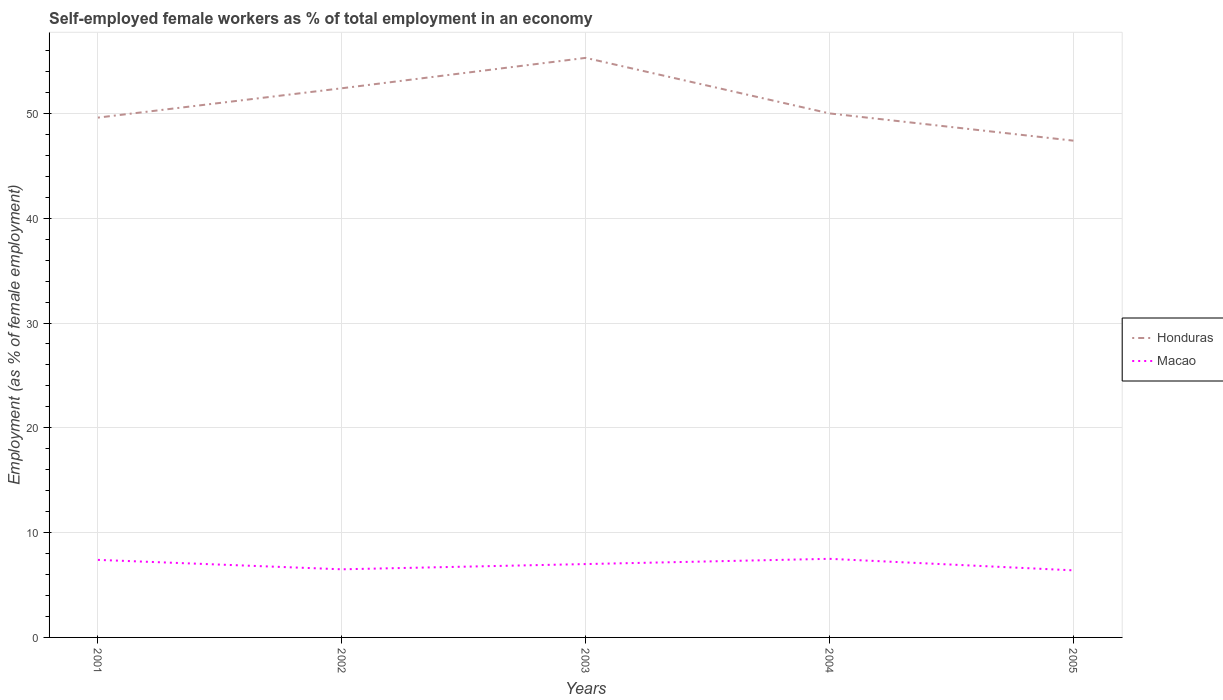How many different coloured lines are there?
Make the answer very short. 2. Does the line corresponding to Honduras intersect with the line corresponding to Macao?
Your answer should be compact. No. Is the number of lines equal to the number of legend labels?
Provide a succinct answer. Yes. Across all years, what is the maximum percentage of self-employed female workers in Honduras?
Your answer should be very brief. 47.4. What is the difference between the highest and the second highest percentage of self-employed female workers in Honduras?
Make the answer very short. 7.9. Is the percentage of self-employed female workers in Macao strictly greater than the percentage of self-employed female workers in Honduras over the years?
Keep it short and to the point. Yes. How many years are there in the graph?
Offer a terse response. 5. How are the legend labels stacked?
Offer a very short reply. Vertical. What is the title of the graph?
Make the answer very short. Self-employed female workers as % of total employment in an economy. Does "Guatemala" appear as one of the legend labels in the graph?
Make the answer very short. No. What is the label or title of the X-axis?
Ensure brevity in your answer.  Years. What is the label or title of the Y-axis?
Your answer should be very brief. Employment (as % of female employment). What is the Employment (as % of female employment) in Honduras in 2001?
Offer a very short reply. 49.6. What is the Employment (as % of female employment) in Macao in 2001?
Keep it short and to the point. 7.4. What is the Employment (as % of female employment) of Honduras in 2002?
Your answer should be compact. 52.4. What is the Employment (as % of female employment) of Macao in 2002?
Offer a very short reply. 6.5. What is the Employment (as % of female employment) in Honduras in 2003?
Your response must be concise. 55.3. What is the Employment (as % of female employment) in Honduras in 2004?
Offer a very short reply. 50. What is the Employment (as % of female employment) of Honduras in 2005?
Provide a succinct answer. 47.4. What is the Employment (as % of female employment) in Macao in 2005?
Offer a terse response. 6.4. Across all years, what is the maximum Employment (as % of female employment) of Honduras?
Make the answer very short. 55.3. Across all years, what is the minimum Employment (as % of female employment) in Honduras?
Keep it short and to the point. 47.4. Across all years, what is the minimum Employment (as % of female employment) in Macao?
Your answer should be compact. 6.4. What is the total Employment (as % of female employment) of Honduras in the graph?
Offer a terse response. 254.7. What is the total Employment (as % of female employment) in Macao in the graph?
Give a very brief answer. 34.8. What is the difference between the Employment (as % of female employment) in Honduras in 2001 and that in 2002?
Provide a succinct answer. -2.8. What is the difference between the Employment (as % of female employment) of Macao in 2001 and that in 2004?
Offer a terse response. -0.1. What is the difference between the Employment (as % of female employment) in Honduras in 2001 and that in 2005?
Give a very brief answer. 2.2. What is the difference between the Employment (as % of female employment) of Macao in 2001 and that in 2005?
Provide a short and direct response. 1. What is the difference between the Employment (as % of female employment) in Honduras in 2002 and that in 2003?
Ensure brevity in your answer.  -2.9. What is the difference between the Employment (as % of female employment) in Macao in 2002 and that in 2003?
Offer a very short reply. -0.5. What is the difference between the Employment (as % of female employment) in Macao in 2002 and that in 2004?
Make the answer very short. -1. What is the difference between the Employment (as % of female employment) of Macao in 2002 and that in 2005?
Provide a succinct answer. 0.1. What is the difference between the Employment (as % of female employment) of Macao in 2003 and that in 2004?
Ensure brevity in your answer.  -0.5. What is the difference between the Employment (as % of female employment) in Honduras in 2003 and that in 2005?
Give a very brief answer. 7.9. What is the difference between the Employment (as % of female employment) in Macao in 2004 and that in 2005?
Ensure brevity in your answer.  1.1. What is the difference between the Employment (as % of female employment) in Honduras in 2001 and the Employment (as % of female employment) in Macao in 2002?
Your response must be concise. 43.1. What is the difference between the Employment (as % of female employment) of Honduras in 2001 and the Employment (as % of female employment) of Macao in 2003?
Keep it short and to the point. 42.6. What is the difference between the Employment (as % of female employment) in Honduras in 2001 and the Employment (as % of female employment) in Macao in 2004?
Offer a very short reply. 42.1. What is the difference between the Employment (as % of female employment) of Honduras in 2001 and the Employment (as % of female employment) of Macao in 2005?
Offer a terse response. 43.2. What is the difference between the Employment (as % of female employment) in Honduras in 2002 and the Employment (as % of female employment) in Macao in 2003?
Make the answer very short. 45.4. What is the difference between the Employment (as % of female employment) in Honduras in 2002 and the Employment (as % of female employment) in Macao in 2004?
Offer a very short reply. 44.9. What is the difference between the Employment (as % of female employment) of Honduras in 2003 and the Employment (as % of female employment) of Macao in 2004?
Ensure brevity in your answer.  47.8. What is the difference between the Employment (as % of female employment) of Honduras in 2003 and the Employment (as % of female employment) of Macao in 2005?
Provide a short and direct response. 48.9. What is the difference between the Employment (as % of female employment) of Honduras in 2004 and the Employment (as % of female employment) of Macao in 2005?
Ensure brevity in your answer.  43.6. What is the average Employment (as % of female employment) in Honduras per year?
Ensure brevity in your answer.  50.94. What is the average Employment (as % of female employment) of Macao per year?
Provide a short and direct response. 6.96. In the year 2001, what is the difference between the Employment (as % of female employment) in Honduras and Employment (as % of female employment) in Macao?
Provide a short and direct response. 42.2. In the year 2002, what is the difference between the Employment (as % of female employment) in Honduras and Employment (as % of female employment) in Macao?
Keep it short and to the point. 45.9. In the year 2003, what is the difference between the Employment (as % of female employment) in Honduras and Employment (as % of female employment) in Macao?
Offer a terse response. 48.3. In the year 2004, what is the difference between the Employment (as % of female employment) of Honduras and Employment (as % of female employment) of Macao?
Keep it short and to the point. 42.5. What is the ratio of the Employment (as % of female employment) in Honduras in 2001 to that in 2002?
Keep it short and to the point. 0.95. What is the ratio of the Employment (as % of female employment) in Macao in 2001 to that in 2002?
Your answer should be compact. 1.14. What is the ratio of the Employment (as % of female employment) in Honduras in 2001 to that in 2003?
Your response must be concise. 0.9. What is the ratio of the Employment (as % of female employment) of Macao in 2001 to that in 2003?
Ensure brevity in your answer.  1.06. What is the ratio of the Employment (as % of female employment) of Macao in 2001 to that in 2004?
Offer a terse response. 0.99. What is the ratio of the Employment (as % of female employment) in Honduras in 2001 to that in 2005?
Your answer should be compact. 1.05. What is the ratio of the Employment (as % of female employment) in Macao in 2001 to that in 2005?
Provide a succinct answer. 1.16. What is the ratio of the Employment (as % of female employment) in Honduras in 2002 to that in 2003?
Provide a short and direct response. 0.95. What is the ratio of the Employment (as % of female employment) of Honduras in 2002 to that in 2004?
Keep it short and to the point. 1.05. What is the ratio of the Employment (as % of female employment) in Macao in 2002 to that in 2004?
Offer a terse response. 0.87. What is the ratio of the Employment (as % of female employment) in Honduras in 2002 to that in 2005?
Provide a short and direct response. 1.11. What is the ratio of the Employment (as % of female employment) in Macao in 2002 to that in 2005?
Keep it short and to the point. 1.02. What is the ratio of the Employment (as % of female employment) in Honduras in 2003 to that in 2004?
Make the answer very short. 1.11. What is the ratio of the Employment (as % of female employment) of Macao in 2003 to that in 2004?
Your response must be concise. 0.93. What is the ratio of the Employment (as % of female employment) of Macao in 2003 to that in 2005?
Provide a succinct answer. 1.09. What is the ratio of the Employment (as % of female employment) of Honduras in 2004 to that in 2005?
Give a very brief answer. 1.05. What is the ratio of the Employment (as % of female employment) in Macao in 2004 to that in 2005?
Keep it short and to the point. 1.17. What is the difference between the highest and the second highest Employment (as % of female employment) in Honduras?
Keep it short and to the point. 2.9. What is the difference between the highest and the second highest Employment (as % of female employment) of Macao?
Provide a succinct answer. 0.1. 